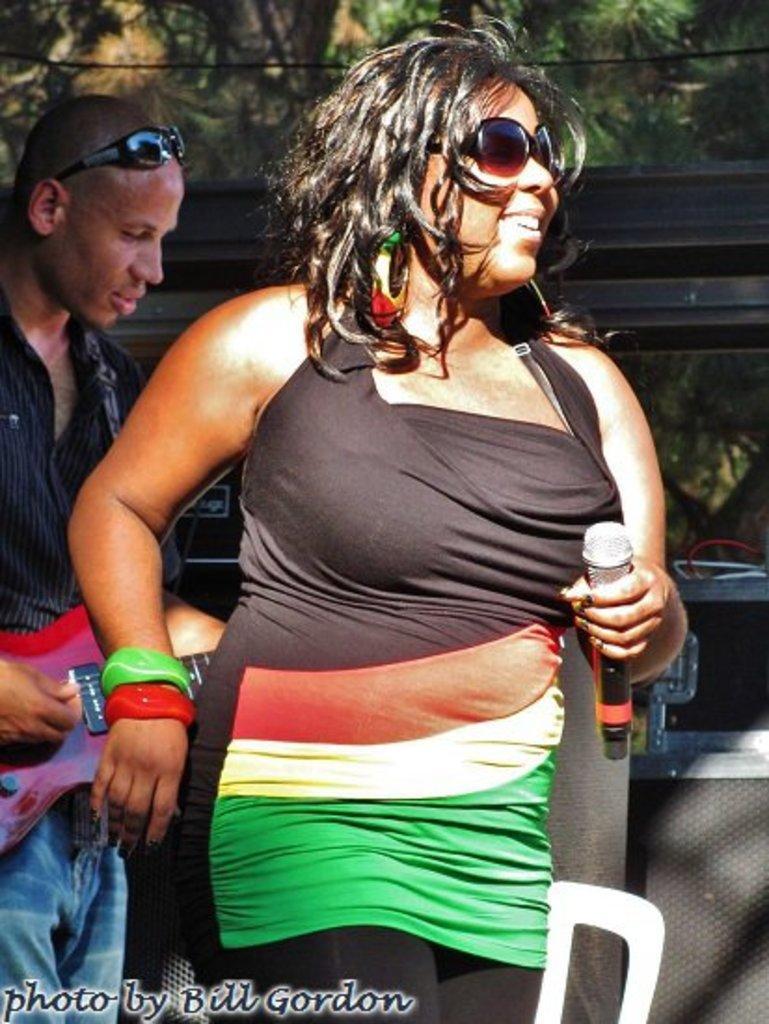Could you give a brief overview of what you see in this image? Here we can see a woman and a man. He is playing guitar and she is holding a mike with her hand. In the background we can see trees. 